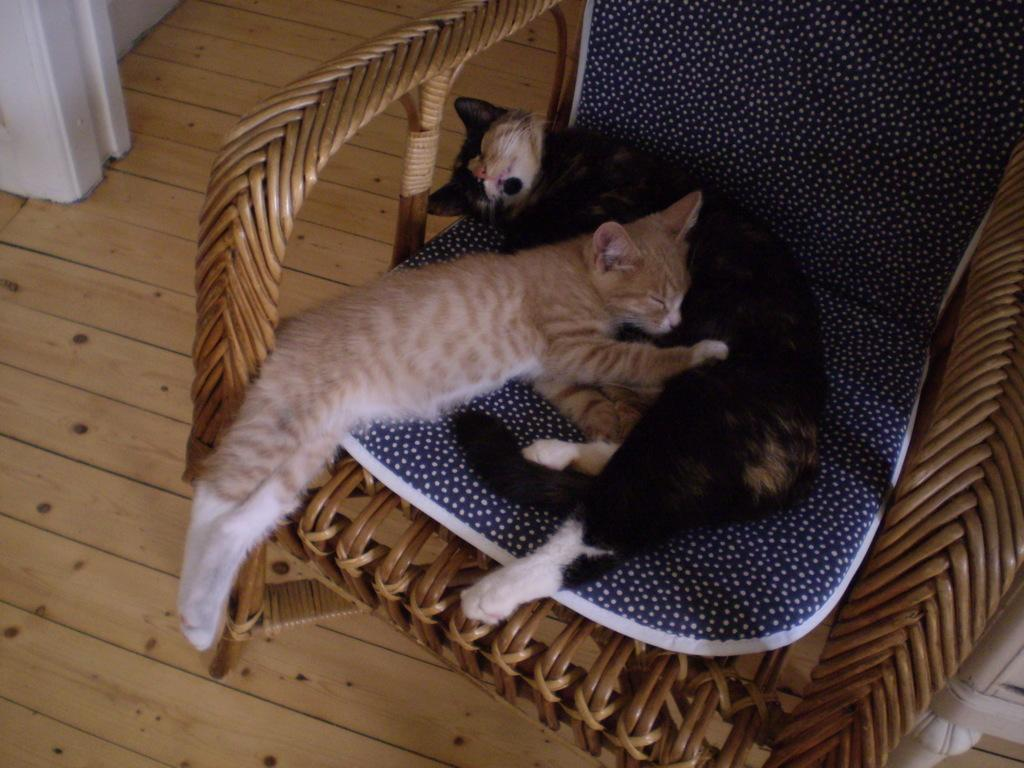What piece of furniture is present in the image? There is a chair in the image. What is placed on the chair? A cushion is placed on the chair. What animals are sitting on the chair? There are cats on the chair. What can be seen in the background of the image? There is a floor visible in the background of the image. What type of plants can be seen growing on the side of the chair? There are no plants visible on the chair or in the image. 